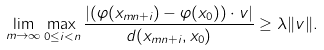<formula> <loc_0><loc_0><loc_500><loc_500>\lim _ { m \to \infty } \max _ { 0 \leq i < n } \frac { | ( \varphi ( x _ { m n + i } ) - \varphi ( x _ { 0 } ) ) \cdot v | } { d ( x _ { m n + i } , x _ { 0 } ) } \geq \lambda \| v \| .</formula> 